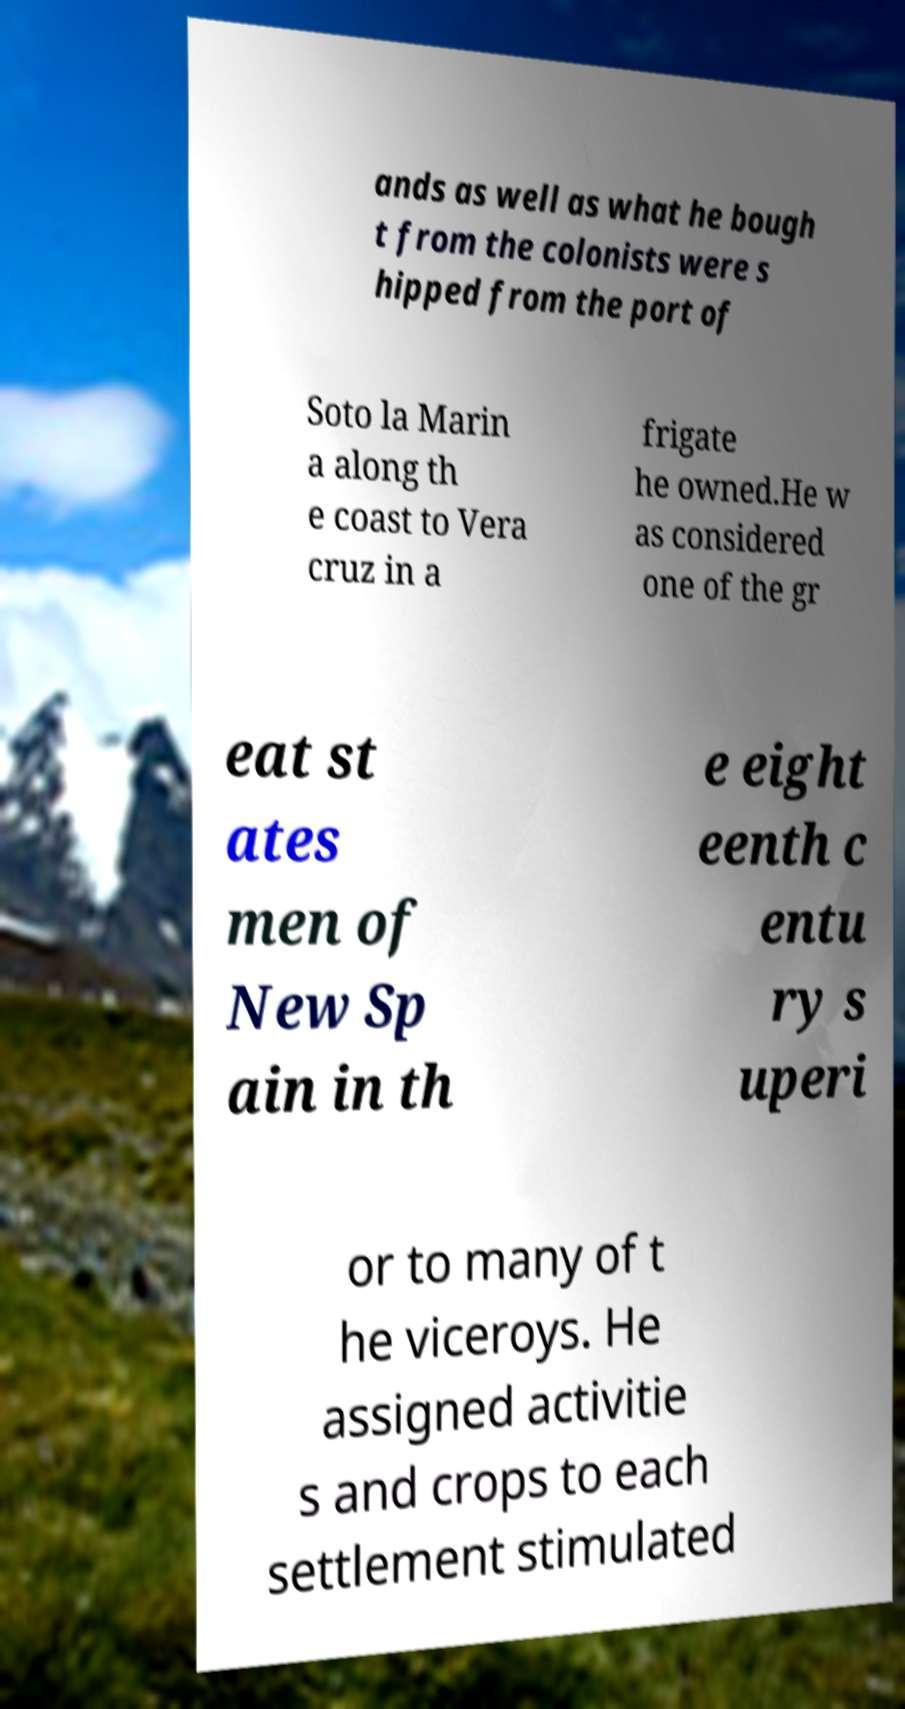Could you assist in decoding the text presented in this image and type it out clearly? ands as well as what he bough t from the colonists were s hipped from the port of Soto la Marin a along th e coast to Vera cruz in a frigate he owned.He w as considered one of the gr eat st ates men of New Sp ain in th e eight eenth c entu ry s uperi or to many of t he viceroys. He assigned activitie s and crops to each settlement stimulated 